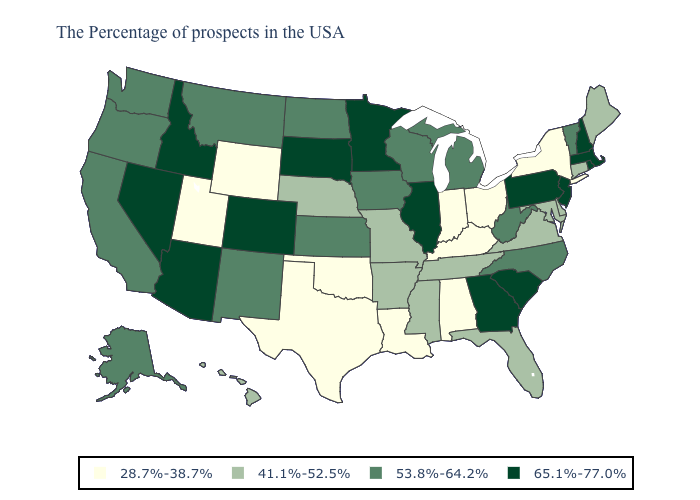What is the value of Missouri?
Short answer required. 41.1%-52.5%. What is the value of Tennessee?
Short answer required. 41.1%-52.5%. Name the states that have a value in the range 41.1%-52.5%?
Concise answer only. Maine, Connecticut, Delaware, Maryland, Virginia, Florida, Tennessee, Mississippi, Missouri, Arkansas, Nebraska, Hawaii. Among the states that border Tennessee , does Georgia have the highest value?
Answer briefly. Yes. What is the highest value in states that border New Mexico?
Quick response, please. 65.1%-77.0%. Which states have the lowest value in the MidWest?
Answer briefly. Ohio, Indiana. Name the states that have a value in the range 53.8%-64.2%?
Answer briefly. Vermont, North Carolina, West Virginia, Michigan, Wisconsin, Iowa, Kansas, North Dakota, New Mexico, Montana, California, Washington, Oregon, Alaska. What is the lowest value in states that border New Jersey?
Concise answer only. 28.7%-38.7%. What is the highest value in the USA?
Be succinct. 65.1%-77.0%. What is the highest value in the West ?
Answer briefly. 65.1%-77.0%. What is the value of New Hampshire?
Keep it brief. 65.1%-77.0%. Among the states that border Washington , does Idaho have the highest value?
Quick response, please. Yes. Name the states that have a value in the range 65.1%-77.0%?
Give a very brief answer. Massachusetts, Rhode Island, New Hampshire, New Jersey, Pennsylvania, South Carolina, Georgia, Illinois, Minnesota, South Dakota, Colorado, Arizona, Idaho, Nevada. Name the states that have a value in the range 65.1%-77.0%?
Be succinct. Massachusetts, Rhode Island, New Hampshire, New Jersey, Pennsylvania, South Carolina, Georgia, Illinois, Minnesota, South Dakota, Colorado, Arizona, Idaho, Nevada. What is the value of Florida?
Write a very short answer. 41.1%-52.5%. 